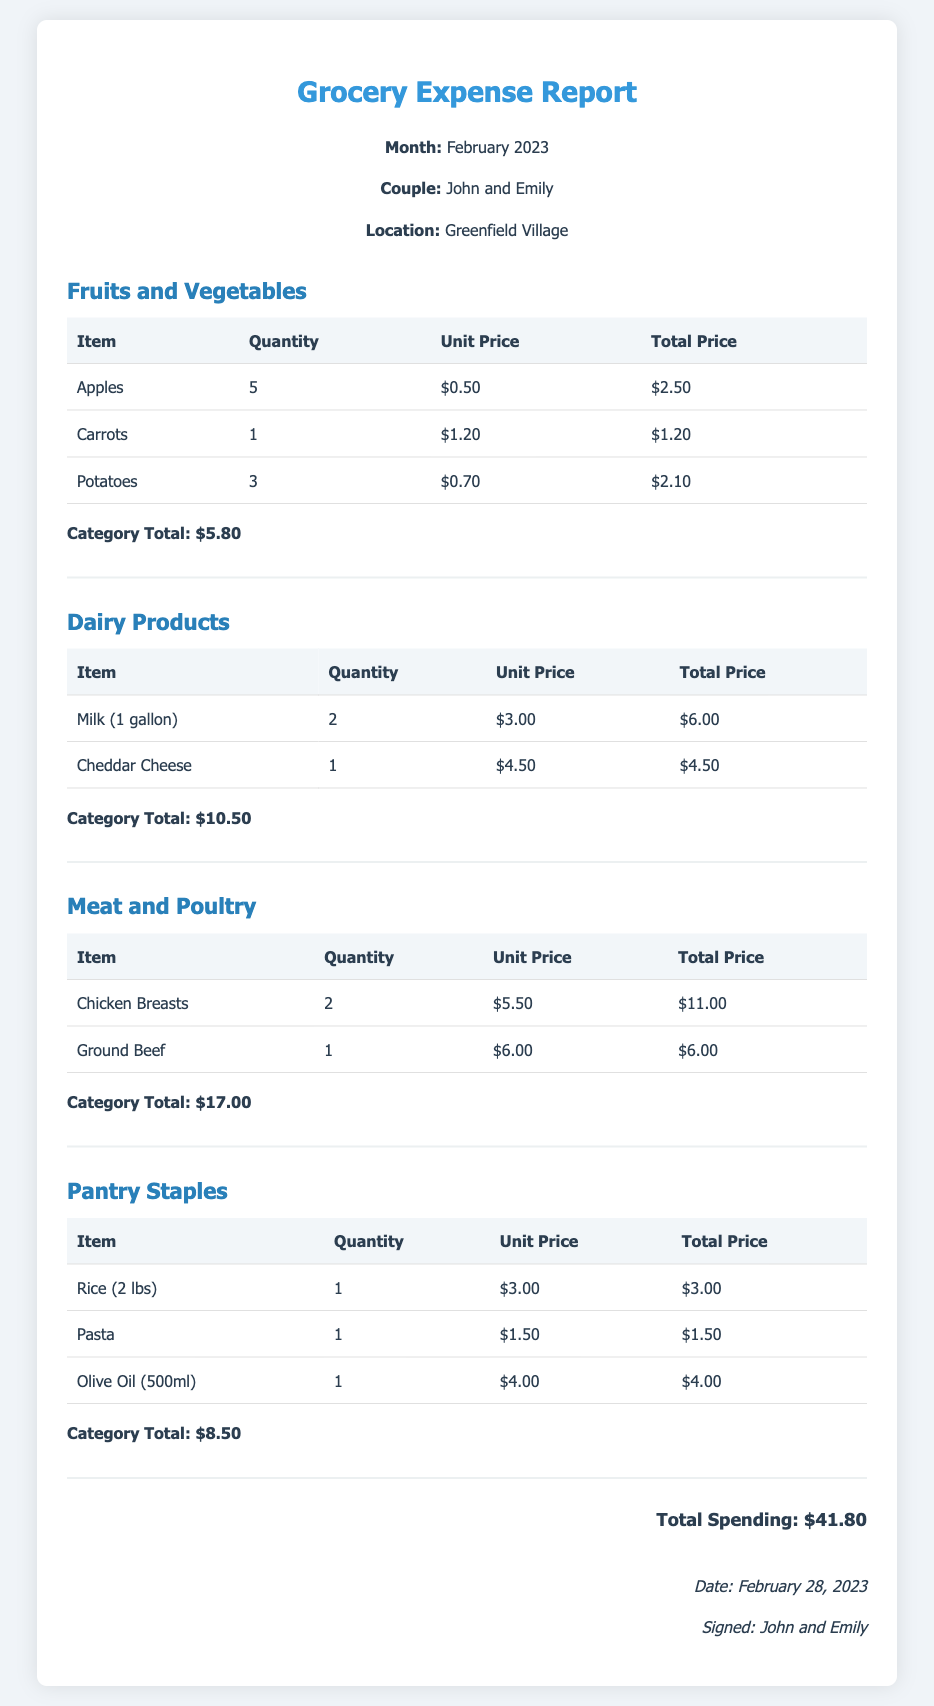what is the month of the report? The report indicates the month for which the grocery expenses are detailed, which is February 2023.
Answer: February 2023 who are the couple mentioned in the report? The header specifies the names of the couple for this expense report.
Answer: John and Emily how much was spent on Dairy Products? The total spending for Dairy Products is listed at the end of that category section.
Answer: $10.50 what is the total spending for the month? The total spending is summarized in a specific section at the end of the report.
Answer: $41.80 how many apples were purchased? The quantity of apples bought is recorded in the Fruits and Vegetables category.
Answer: 5 which item in the Pantry Staples category had the highest unit price? The unit prices for each item in the Pantry Staples section indicate that Olive Oil has the highest price.
Answer: Olive Oil how many Chicken Breasts were bought? The quantity of Chicken Breasts is noted in the Meat and Poultry category.
Answer: 2 what is the category total for Fruits and Vegetables? The total for the Fruits and Vegetables category is provided at the bottom of that section.
Answer: $5.80 when was the document signed? The date of signing is indicated at the bottom of the report.
Answer: February 28, 2023 